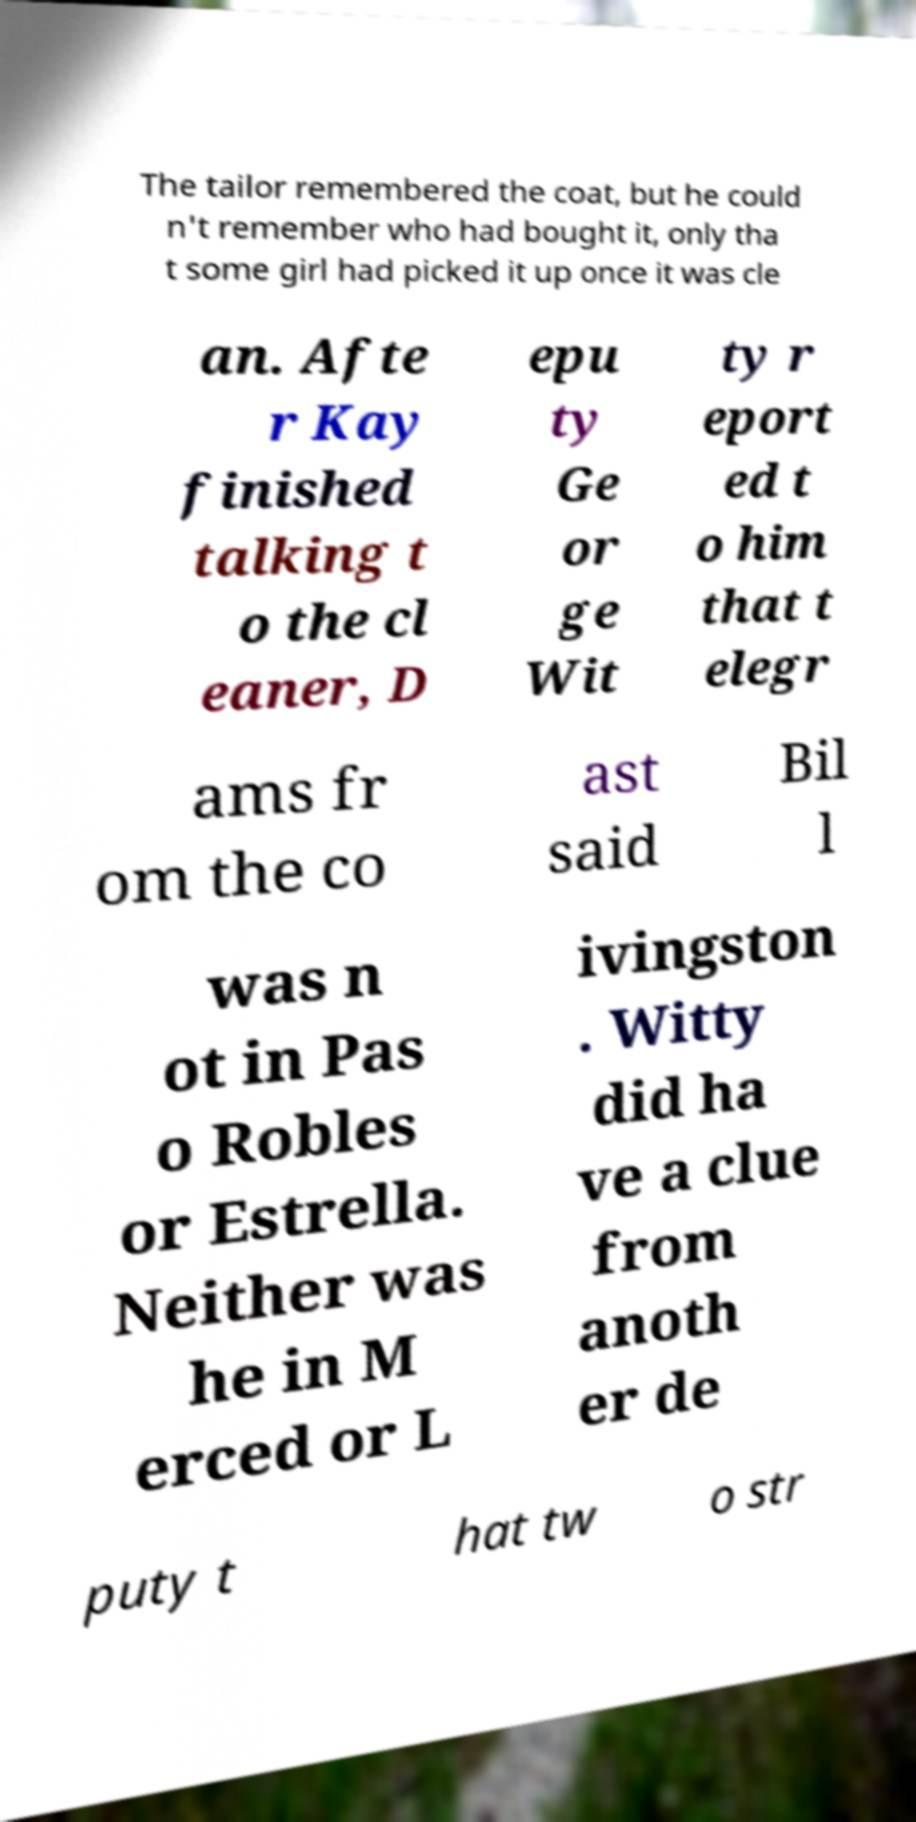What messages or text are displayed in this image? I need them in a readable, typed format. The tailor remembered the coat, but he could n't remember who had bought it, only tha t some girl had picked it up once it was cle an. Afte r Kay finished talking t o the cl eaner, D epu ty Ge or ge Wit ty r eport ed t o him that t elegr ams fr om the co ast said Bil l was n ot in Pas o Robles or Estrella. Neither was he in M erced or L ivingston . Witty did ha ve a clue from anoth er de puty t hat tw o str 